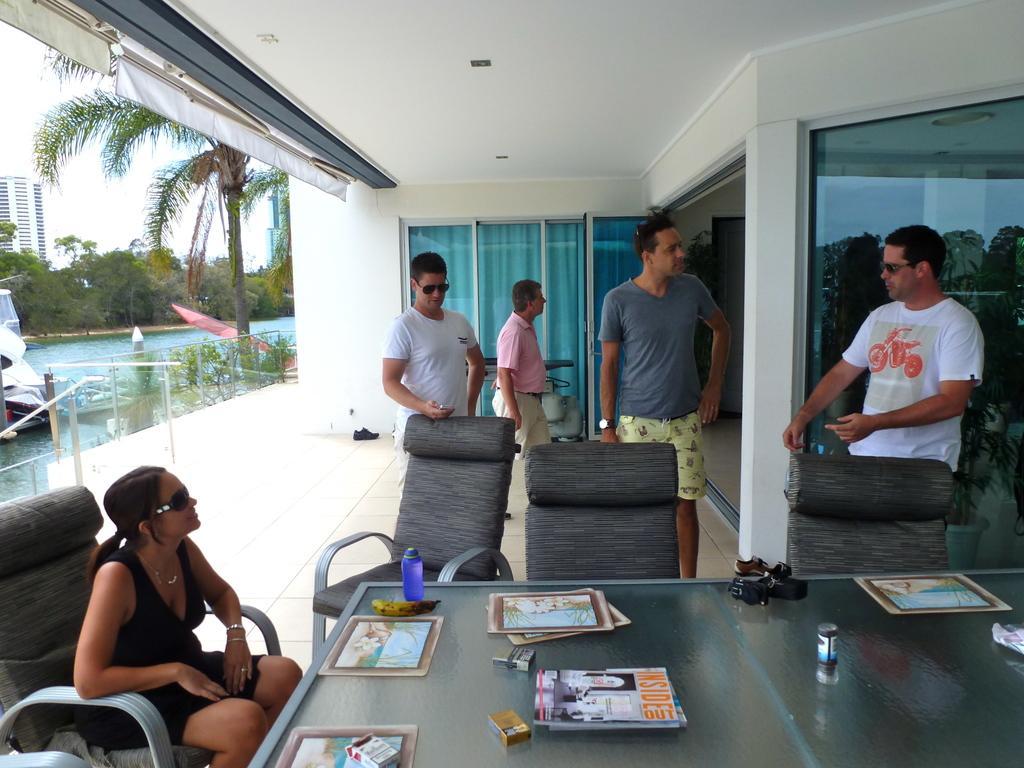Describe this image in one or two sentences. This is a picture taken in a room, there are four persons standing on the floor. The woman in black dress was sitting on a chair in front of the people there is a table on the table there are cigarette packets, books, tin, camera, banana and some items. Behind the people there are glass windows, water on water there is a boat, trees, building and sky. On top there is a ceiling lights. 